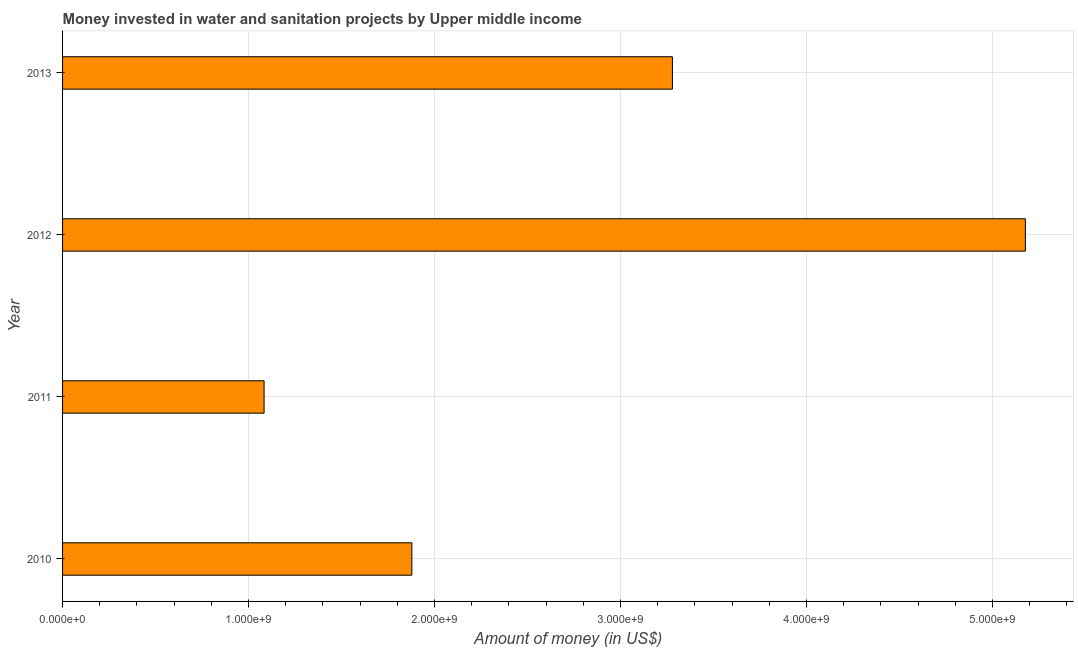Does the graph contain grids?
Provide a short and direct response. Yes. What is the title of the graph?
Provide a succinct answer. Money invested in water and sanitation projects by Upper middle income. What is the label or title of the X-axis?
Give a very brief answer. Amount of money (in US$). What is the investment in 2010?
Give a very brief answer. 1.88e+09. Across all years, what is the maximum investment?
Your answer should be compact. 5.18e+09. Across all years, what is the minimum investment?
Provide a succinct answer. 1.08e+09. In which year was the investment maximum?
Ensure brevity in your answer.  2012. In which year was the investment minimum?
Offer a terse response. 2011. What is the sum of the investment?
Ensure brevity in your answer.  1.14e+1. What is the difference between the investment in 2011 and 2013?
Make the answer very short. -2.20e+09. What is the average investment per year?
Ensure brevity in your answer.  2.85e+09. What is the median investment?
Offer a terse response. 2.58e+09. In how many years, is the investment greater than 4200000000 US$?
Keep it short and to the point. 1. What is the ratio of the investment in 2010 to that in 2012?
Offer a terse response. 0.36. Is the investment in 2011 less than that in 2013?
Your answer should be very brief. Yes. What is the difference between the highest and the second highest investment?
Your answer should be very brief. 1.90e+09. What is the difference between the highest and the lowest investment?
Provide a succinct answer. 4.09e+09. In how many years, is the investment greater than the average investment taken over all years?
Provide a succinct answer. 2. Are all the bars in the graph horizontal?
Make the answer very short. Yes. How many years are there in the graph?
Keep it short and to the point. 4. What is the difference between two consecutive major ticks on the X-axis?
Your answer should be very brief. 1.00e+09. What is the Amount of money (in US$) of 2010?
Provide a short and direct response. 1.88e+09. What is the Amount of money (in US$) in 2011?
Provide a succinct answer. 1.08e+09. What is the Amount of money (in US$) of 2012?
Give a very brief answer. 5.18e+09. What is the Amount of money (in US$) of 2013?
Make the answer very short. 3.28e+09. What is the difference between the Amount of money (in US$) in 2010 and 2011?
Provide a succinct answer. 7.94e+08. What is the difference between the Amount of money (in US$) in 2010 and 2012?
Ensure brevity in your answer.  -3.30e+09. What is the difference between the Amount of money (in US$) in 2010 and 2013?
Provide a succinct answer. -1.40e+09. What is the difference between the Amount of money (in US$) in 2011 and 2012?
Ensure brevity in your answer.  -4.09e+09. What is the difference between the Amount of money (in US$) in 2011 and 2013?
Your answer should be very brief. -2.20e+09. What is the difference between the Amount of money (in US$) in 2012 and 2013?
Offer a very short reply. 1.90e+09. What is the ratio of the Amount of money (in US$) in 2010 to that in 2011?
Give a very brief answer. 1.73. What is the ratio of the Amount of money (in US$) in 2010 to that in 2012?
Provide a succinct answer. 0.36. What is the ratio of the Amount of money (in US$) in 2010 to that in 2013?
Provide a short and direct response. 0.57. What is the ratio of the Amount of money (in US$) in 2011 to that in 2012?
Your answer should be compact. 0.21. What is the ratio of the Amount of money (in US$) in 2011 to that in 2013?
Keep it short and to the point. 0.33. What is the ratio of the Amount of money (in US$) in 2012 to that in 2013?
Make the answer very short. 1.58. 